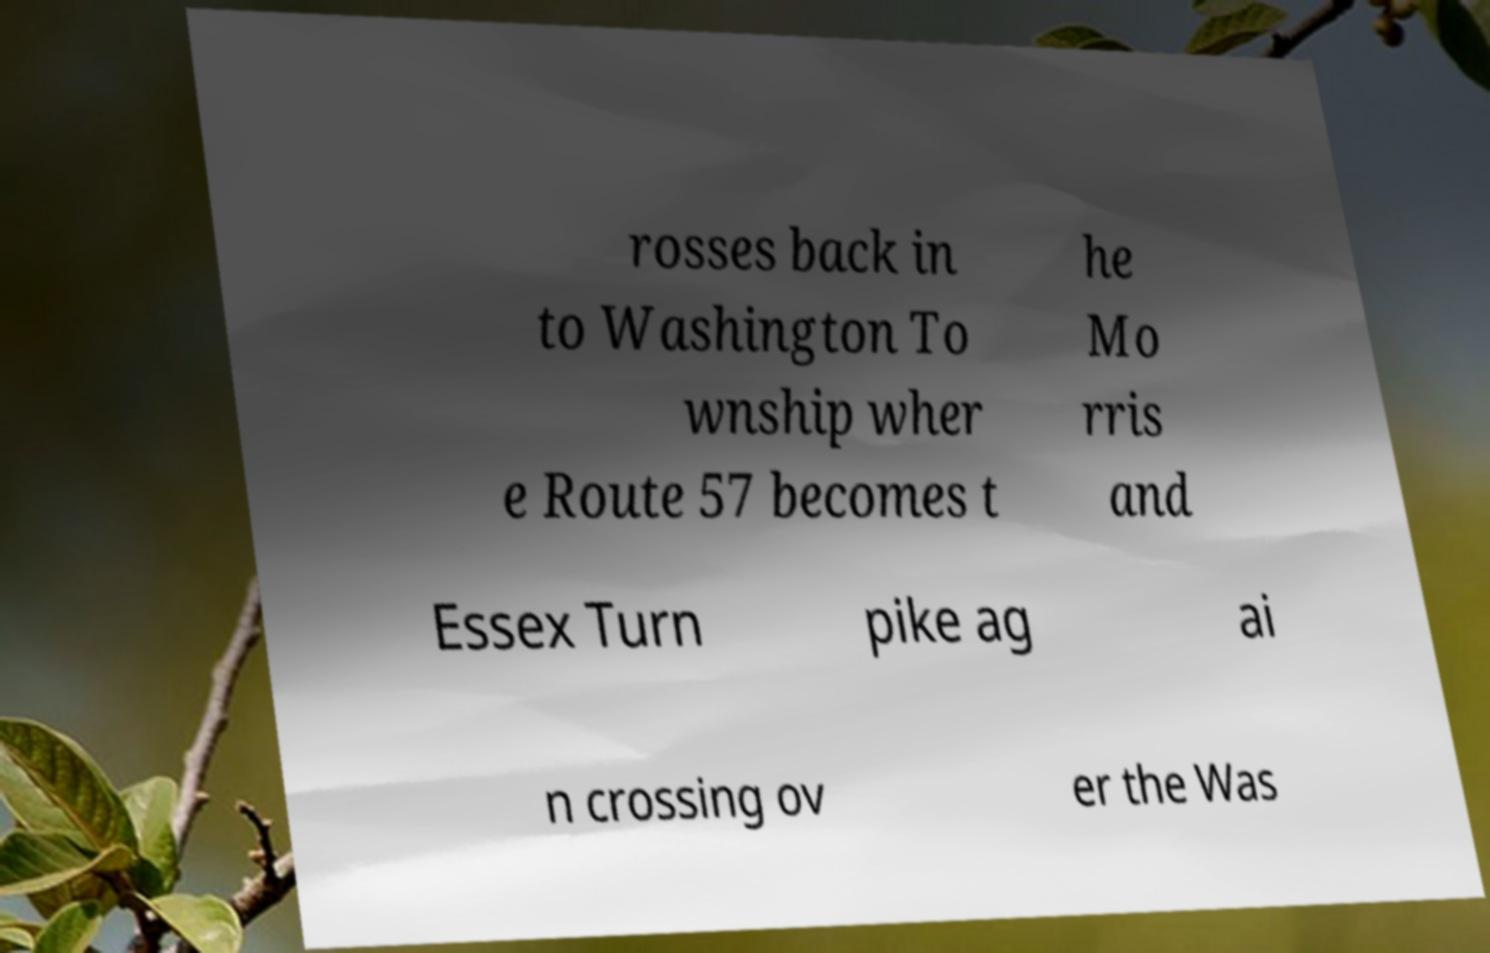What messages or text are displayed in this image? I need them in a readable, typed format. rosses back in to Washington To wnship wher e Route 57 becomes t he Mo rris and Essex Turn pike ag ai n crossing ov er the Was 